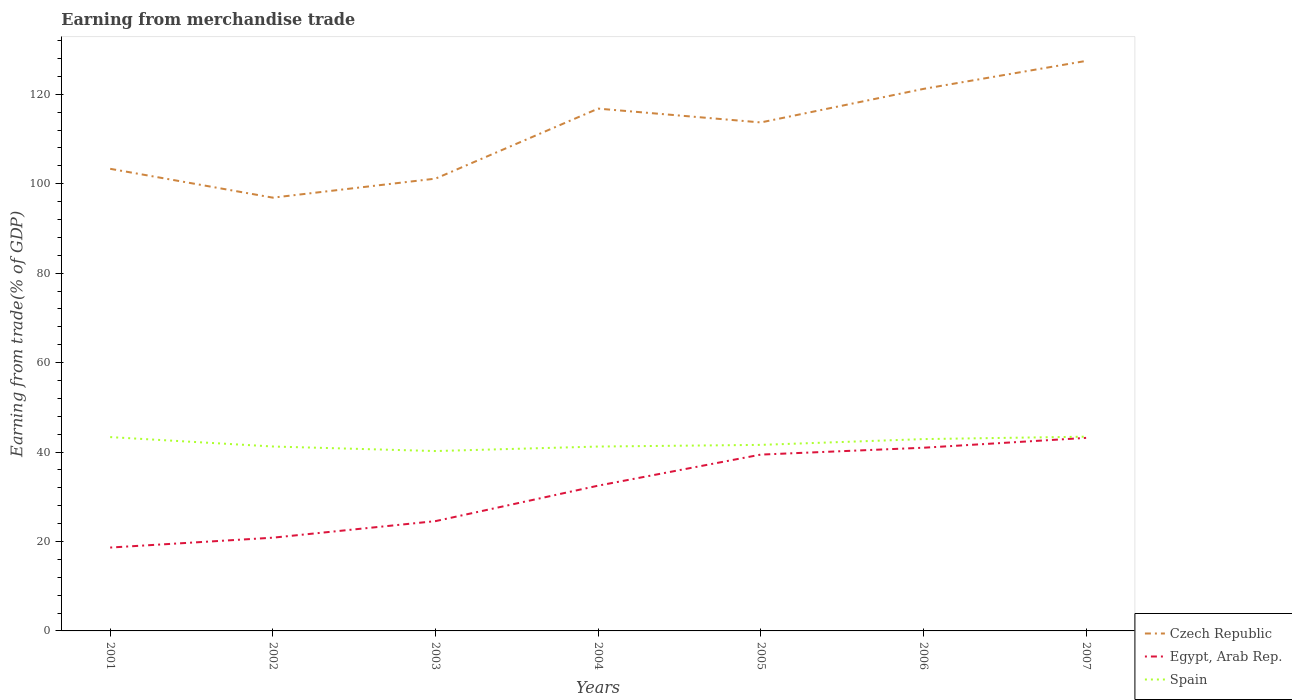Is the number of lines equal to the number of legend labels?
Provide a short and direct response. Yes. Across all years, what is the maximum earnings from trade in Egypt, Arab Rep.?
Provide a succinct answer. 18.64. In which year was the earnings from trade in Czech Republic maximum?
Your response must be concise. 2002. What is the total earnings from trade in Spain in the graph?
Your response must be concise. -0.36. What is the difference between the highest and the second highest earnings from trade in Czech Republic?
Provide a succinct answer. 30.58. Is the earnings from trade in Spain strictly greater than the earnings from trade in Czech Republic over the years?
Offer a terse response. Yes. How many lines are there?
Your answer should be compact. 3. How many years are there in the graph?
Ensure brevity in your answer.  7. Does the graph contain grids?
Offer a terse response. No. Where does the legend appear in the graph?
Provide a short and direct response. Bottom right. What is the title of the graph?
Your response must be concise. Earning from merchandise trade. What is the label or title of the Y-axis?
Give a very brief answer. Earning from trade(% of GDP). What is the Earning from trade(% of GDP) in Czech Republic in 2001?
Your answer should be compact. 103.33. What is the Earning from trade(% of GDP) of Egypt, Arab Rep. in 2001?
Your response must be concise. 18.64. What is the Earning from trade(% of GDP) in Spain in 2001?
Provide a short and direct response. 43.34. What is the Earning from trade(% of GDP) in Czech Republic in 2002?
Your answer should be very brief. 96.88. What is the Earning from trade(% of GDP) of Egypt, Arab Rep. in 2002?
Provide a short and direct response. 20.85. What is the Earning from trade(% of GDP) of Spain in 2002?
Your answer should be very brief. 41.24. What is the Earning from trade(% of GDP) in Czech Republic in 2003?
Make the answer very short. 101.14. What is the Earning from trade(% of GDP) in Egypt, Arab Rep. in 2003?
Ensure brevity in your answer.  24.55. What is the Earning from trade(% of GDP) in Spain in 2003?
Keep it short and to the point. 40.22. What is the Earning from trade(% of GDP) in Czech Republic in 2004?
Your answer should be compact. 116.79. What is the Earning from trade(% of GDP) in Egypt, Arab Rep. in 2004?
Your answer should be compact. 32.48. What is the Earning from trade(% of GDP) in Spain in 2004?
Provide a short and direct response. 41.23. What is the Earning from trade(% of GDP) of Czech Republic in 2005?
Ensure brevity in your answer.  113.7. What is the Earning from trade(% of GDP) of Egypt, Arab Rep. in 2005?
Your response must be concise. 39.43. What is the Earning from trade(% of GDP) of Spain in 2005?
Keep it short and to the point. 41.6. What is the Earning from trade(% of GDP) in Czech Republic in 2006?
Your answer should be very brief. 121.2. What is the Earning from trade(% of GDP) of Egypt, Arab Rep. in 2006?
Your response must be concise. 40.96. What is the Earning from trade(% of GDP) in Spain in 2006?
Ensure brevity in your answer.  42.89. What is the Earning from trade(% of GDP) in Czech Republic in 2007?
Offer a terse response. 127.46. What is the Earning from trade(% of GDP) in Egypt, Arab Rep. in 2007?
Your response must be concise. 43.17. What is the Earning from trade(% of GDP) of Spain in 2007?
Ensure brevity in your answer.  43.44. Across all years, what is the maximum Earning from trade(% of GDP) of Czech Republic?
Keep it short and to the point. 127.46. Across all years, what is the maximum Earning from trade(% of GDP) of Egypt, Arab Rep.?
Offer a very short reply. 43.17. Across all years, what is the maximum Earning from trade(% of GDP) of Spain?
Give a very brief answer. 43.44. Across all years, what is the minimum Earning from trade(% of GDP) in Czech Republic?
Keep it short and to the point. 96.88. Across all years, what is the minimum Earning from trade(% of GDP) in Egypt, Arab Rep.?
Keep it short and to the point. 18.64. Across all years, what is the minimum Earning from trade(% of GDP) in Spain?
Your answer should be compact. 40.22. What is the total Earning from trade(% of GDP) of Czech Republic in the graph?
Keep it short and to the point. 780.5. What is the total Earning from trade(% of GDP) of Egypt, Arab Rep. in the graph?
Your answer should be very brief. 220.08. What is the total Earning from trade(% of GDP) in Spain in the graph?
Keep it short and to the point. 293.96. What is the difference between the Earning from trade(% of GDP) of Czech Republic in 2001 and that in 2002?
Offer a terse response. 6.45. What is the difference between the Earning from trade(% of GDP) in Egypt, Arab Rep. in 2001 and that in 2002?
Offer a terse response. -2.21. What is the difference between the Earning from trade(% of GDP) in Spain in 2001 and that in 2002?
Ensure brevity in your answer.  2.1. What is the difference between the Earning from trade(% of GDP) in Czech Republic in 2001 and that in 2003?
Your response must be concise. 2.2. What is the difference between the Earning from trade(% of GDP) in Egypt, Arab Rep. in 2001 and that in 2003?
Provide a succinct answer. -5.91. What is the difference between the Earning from trade(% of GDP) in Spain in 2001 and that in 2003?
Keep it short and to the point. 3.12. What is the difference between the Earning from trade(% of GDP) in Czech Republic in 2001 and that in 2004?
Provide a succinct answer. -13.46. What is the difference between the Earning from trade(% of GDP) in Egypt, Arab Rep. in 2001 and that in 2004?
Make the answer very short. -13.84. What is the difference between the Earning from trade(% of GDP) of Spain in 2001 and that in 2004?
Ensure brevity in your answer.  2.11. What is the difference between the Earning from trade(% of GDP) in Czech Republic in 2001 and that in 2005?
Offer a very short reply. -10.37. What is the difference between the Earning from trade(% of GDP) in Egypt, Arab Rep. in 2001 and that in 2005?
Your answer should be very brief. -20.79. What is the difference between the Earning from trade(% of GDP) of Spain in 2001 and that in 2005?
Keep it short and to the point. 1.74. What is the difference between the Earning from trade(% of GDP) in Czech Republic in 2001 and that in 2006?
Ensure brevity in your answer.  -17.87. What is the difference between the Earning from trade(% of GDP) in Egypt, Arab Rep. in 2001 and that in 2006?
Ensure brevity in your answer.  -22.32. What is the difference between the Earning from trade(% of GDP) of Spain in 2001 and that in 2006?
Keep it short and to the point. 0.45. What is the difference between the Earning from trade(% of GDP) in Czech Republic in 2001 and that in 2007?
Provide a short and direct response. -24.13. What is the difference between the Earning from trade(% of GDP) in Egypt, Arab Rep. in 2001 and that in 2007?
Give a very brief answer. -24.53. What is the difference between the Earning from trade(% of GDP) in Spain in 2001 and that in 2007?
Make the answer very short. -0.1. What is the difference between the Earning from trade(% of GDP) of Czech Republic in 2002 and that in 2003?
Make the answer very short. -4.26. What is the difference between the Earning from trade(% of GDP) of Egypt, Arab Rep. in 2002 and that in 2003?
Give a very brief answer. -3.7. What is the difference between the Earning from trade(% of GDP) of Spain in 2002 and that in 2003?
Your answer should be very brief. 1.02. What is the difference between the Earning from trade(% of GDP) in Czech Republic in 2002 and that in 2004?
Your answer should be very brief. -19.91. What is the difference between the Earning from trade(% of GDP) of Egypt, Arab Rep. in 2002 and that in 2004?
Make the answer very short. -11.63. What is the difference between the Earning from trade(% of GDP) in Spain in 2002 and that in 2004?
Provide a succinct answer. 0.01. What is the difference between the Earning from trade(% of GDP) in Czech Republic in 2002 and that in 2005?
Keep it short and to the point. -16.82. What is the difference between the Earning from trade(% of GDP) in Egypt, Arab Rep. in 2002 and that in 2005?
Your answer should be compact. -18.58. What is the difference between the Earning from trade(% of GDP) in Spain in 2002 and that in 2005?
Your response must be concise. -0.36. What is the difference between the Earning from trade(% of GDP) in Czech Republic in 2002 and that in 2006?
Keep it short and to the point. -24.32. What is the difference between the Earning from trade(% of GDP) of Egypt, Arab Rep. in 2002 and that in 2006?
Give a very brief answer. -20.11. What is the difference between the Earning from trade(% of GDP) of Spain in 2002 and that in 2006?
Your response must be concise. -1.66. What is the difference between the Earning from trade(% of GDP) in Czech Republic in 2002 and that in 2007?
Offer a very short reply. -30.58. What is the difference between the Earning from trade(% of GDP) in Egypt, Arab Rep. in 2002 and that in 2007?
Your answer should be compact. -22.32. What is the difference between the Earning from trade(% of GDP) of Spain in 2002 and that in 2007?
Make the answer very short. -2.2. What is the difference between the Earning from trade(% of GDP) of Czech Republic in 2003 and that in 2004?
Keep it short and to the point. -15.65. What is the difference between the Earning from trade(% of GDP) in Egypt, Arab Rep. in 2003 and that in 2004?
Make the answer very short. -7.93. What is the difference between the Earning from trade(% of GDP) of Spain in 2003 and that in 2004?
Offer a terse response. -1.01. What is the difference between the Earning from trade(% of GDP) of Czech Republic in 2003 and that in 2005?
Keep it short and to the point. -12.56. What is the difference between the Earning from trade(% of GDP) of Egypt, Arab Rep. in 2003 and that in 2005?
Ensure brevity in your answer.  -14.88. What is the difference between the Earning from trade(% of GDP) in Spain in 2003 and that in 2005?
Provide a succinct answer. -1.38. What is the difference between the Earning from trade(% of GDP) in Czech Republic in 2003 and that in 2006?
Give a very brief answer. -20.06. What is the difference between the Earning from trade(% of GDP) in Egypt, Arab Rep. in 2003 and that in 2006?
Your answer should be compact. -16.41. What is the difference between the Earning from trade(% of GDP) of Spain in 2003 and that in 2006?
Keep it short and to the point. -2.67. What is the difference between the Earning from trade(% of GDP) of Czech Republic in 2003 and that in 2007?
Your response must be concise. -26.32. What is the difference between the Earning from trade(% of GDP) in Egypt, Arab Rep. in 2003 and that in 2007?
Your answer should be very brief. -18.62. What is the difference between the Earning from trade(% of GDP) of Spain in 2003 and that in 2007?
Offer a terse response. -3.22. What is the difference between the Earning from trade(% of GDP) in Czech Republic in 2004 and that in 2005?
Make the answer very short. 3.09. What is the difference between the Earning from trade(% of GDP) in Egypt, Arab Rep. in 2004 and that in 2005?
Make the answer very short. -6.94. What is the difference between the Earning from trade(% of GDP) in Spain in 2004 and that in 2005?
Provide a short and direct response. -0.37. What is the difference between the Earning from trade(% of GDP) in Czech Republic in 2004 and that in 2006?
Provide a succinct answer. -4.41. What is the difference between the Earning from trade(% of GDP) in Egypt, Arab Rep. in 2004 and that in 2006?
Give a very brief answer. -8.48. What is the difference between the Earning from trade(% of GDP) of Spain in 2004 and that in 2006?
Offer a very short reply. -1.67. What is the difference between the Earning from trade(% of GDP) in Czech Republic in 2004 and that in 2007?
Provide a succinct answer. -10.67. What is the difference between the Earning from trade(% of GDP) in Egypt, Arab Rep. in 2004 and that in 2007?
Your response must be concise. -10.68. What is the difference between the Earning from trade(% of GDP) of Spain in 2004 and that in 2007?
Provide a short and direct response. -2.21. What is the difference between the Earning from trade(% of GDP) in Czech Republic in 2005 and that in 2006?
Offer a very short reply. -7.5. What is the difference between the Earning from trade(% of GDP) in Egypt, Arab Rep. in 2005 and that in 2006?
Provide a succinct answer. -1.53. What is the difference between the Earning from trade(% of GDP) in Spain in 2005 and that in 2006?
Offer a terse response. -1.29. What is the difference between the Earning from trade(% of GDP) of Czech Republic in 2005 and that in 2007?
Provide a succinct answer. -13.76. What is the difference between the Earning from trade(% of GDP) of Egypt, Arab Rep. in 2005 and that in 2007?
Provide a short and direct response. -3.74. What is the difference between the Earning from trade(% of GDP) of Spain in 2005 and that in 2007?
Offer a terse response. -1.84. What is the difference between the Earning from trade(% of GDP) of Czech Republic in 2006 and that in 2007?
Keep it short and to the point. -6.26. What is the difference between the Earning from trade(% of GDP) of Egypt, Arab Rep. in 2006 and that in 2007?
Keep it short and to the point. -2.2. What is the difference between the Earning from trade(% of GDP) in Spain in 2006 and that in 2007?
Ensure brevity in your answer.  -0.54. What is the difference between the Earning from trade(% of GDP) of Czech Republic in 2001 and the Earning from trade(% of GDP) of Egypt, Arab Rep. in 2002?
Your response must be concise. 82.48. What is the difference between the Earning from trade(% of GDP) of Czech Republic in 2001 and the Earning from trade(% of GDP) of Spain in 2002?
Offer a terse response. 62.09. What is the difference between the Earning from trade(% of GDP) of Egypt, Arab Rep. in 2001 and the Earning from trade(% of GDP) of Spain in 2002?
Provide a short and direct response. -22.6. What is the difference between the Earning from trade(% of GDP) in Czech Republic in 2001 and the Earning from trade(% of GDP) in Egypt, Arab Rep. in 2003?
Make the answer very short. 78.78. What is the difference between the Earning from trade(% of GDP) of Czech Republic in 2001 and the Earning from trade(% of GDP) of Spain in 2003?
Ensure brevity in your answer.  63.11. What is the difference between the Earning from trade(% of GDP) of Egypt, Arab Rep. in 2001 and the Earning from trade(% of GDP) of Spain in 2003?
Your response must be concise. -21.58. What is the difference between the Earning from trade(% of GDP) of Czech Republic in 2001 and the Earning from trade(% of GDP) of Egypt, Arab Rep. in 2004?
Your response must be concise. 70.85. What is the difference between the Earning from trade(% of GDP) of Czech Republic in 2001 and the Earning from trade(% of GDP) of Spain in 2004?
Make the answer very short. 62.11. What is the difference between the Earning from trade(% of GDP) in Egypt, Arab Rep. in 2001 and the Earning from trade(% of GDP) in Spain in 2004?
Your answer should be compact. -22.59. What is the difference between the Earning from trade(% of GDP) of Czech Republic in 2001 and the Earning from trade(% of GDP) of Egypt, Arab Rep. in 2005?
Keep it short and to the point. 63.91. What is the difference between the Earning from trade(% of GDP) in Czech Republic in 2001 and the Earning from trade(% of GDP) in Spain in 2005?
Ensure brevity in your answer.  61.73. What is the difference between the Earning from trade(% of GDP) of Egypt, Arab Rep. in 2001 and the Earning from trade(% of GDP) of Spain in 2005?
Offer a terse response. -22.96. What is the difference between the Earning from trade(% of GDP) in Czech Republic in 2001 and the Earning from trade(% of GDP) in Egypt, Arab Rep. in 2006?
Keep it short and to the point. 62.37. What is the difference between the Earning from trade(% of GDP) of Czech Republic in 2001 and the Earning from trade(% of GDP) of Spain in 2006?
Make the answer very short. 60.44. What is the difference between the Earning from trade(% of GDP) in Egypt, Arab Rep. in 2001 and the Earning from trade(% of GDP) in Spain in 2006?
Give a very brief answer. -24.25. What is the difference between the Earning from trade(% of GDP) of Czech Republic in 2001 and the Earning from trade(% of GDP) of Egypt, Arab Rep. in 2007?
Your answer should be compact. 60.17. What is the difference between the Earning from trade(% of GDP) of Czech Republic in 2001 and the Earning from trade(% of GDP) of Spain in 2007?
Provide a succinct answer. 59.89. What is the difference between the Earning from trade(% of GDP) in Egypt, Arab Rep. in 2001 and the Earning from trade(% of GDP) in Spain in 2007?
Your answer should be very brief. -24.8. What is the difference between the Earning from trade(% of GDP) of Czech Republic in 2002 and the Earning from trade(% of GDP) of Egypt, Arab Rep. in 2003?
Offer a terse response. 72.33. What is the difference between the Earning from trade(% of GDP) of Czech Republic in 2002 and the Earning from trade(% of GDP) of Spain in 2003?
Make the answer very short. 56.66. What is the difference between the Earning from trade(% of GDP) in Egypt, Arab Rep. in 2002 and the Earning from trade(% of GDP) in Spain in 2003?
Make the answer very short. -19.37. What is the difference between the Earning from trade(% of GDP) of Czech Republic in 2002 and the Earning from trade(% of GDP) of Egypt, Arab Rep. in 2004?
Give a very brief answer. 64.4. What is the difference between the Earning from trade(% of GDP) in Czech Republic in 2002 and the Earning from trade(% of GDP) in Spain in 2004?
Provide a succinct answer. 55.65. What is the difference between the Earning from trade(% of GDP) in Egypt, Arab Rep. in 2002 and the Earning from trade(% of GDP) in Spain in 2004?
Offer a very short reply. -20.38. What is the difference between the Earning from trade(% of GDP) of Czech Republic in 2002 and the Earning from trade(% of GDP) of Egypt, Arab Rep. in 2005?
Give a very brief answer. 57.45. What is the difference between the Earning from trade(% of GDP) of Czech Republic in 2002 and the Earning from trade(% of GDP) of Spain in 2005?
Keep it short and to the point. 55.28. What is the difference between the Earning from trade(% of GDP) in Egypt, Arab Rep. in 2002 and the Earning from trade(% of GDP) in Spain in 2005?
Provide a succinct answer. -20.75. What is the difference between the Earning from trade(% of GDP) in Czech Republic in 2002 and the Earning from trade(% of GDP) in Egypt, Arab Rep. in 2006?
Make the answer very short. 55.92. What is the difference between the Earning from trade(% of GDP) in Czech Republic in 2002 and the Earning from trade(% of GDP) in Spain in 2006?
Your answer should be very brief. 53.99. What is the difference between the Earning from trade(% of GDP) in Egypt, Arab Rep. in 2002 and the Earning from trade(% of GDP) in Spain in 2006?
Make the answer very short. -22.05. What is the difference between the Earning from trade(% of GDP) in Czech Republic in 2002 and the Earning from trade(% of GDP) in Egypt, Arab Rep. in 2007?
Your answer should be compact. 53.71. What is the difference between the Earning from trade(% of GDP) in Czech Republic in 2002 and the Earning from trade(% of GDP) in Spain in 2007?
Your answer should be compact. 53.44. What is the difference between the Earning from trade(% of GDP) of Egypt, Arab Rep. in 2002 and the Earning from trade(% of GDP) of Spain in 2007?
Keep it short and to the point. -22.59. What is the difference between the Earning from trade(% of GDP) in Czech Republic in 2003 and the Earning from trade(% of GDP) in Egypt, Arab Rep. in 2004?
Offer a very short reply. 68.65. What is the difference between the Earning from trade(% of GDP) in Czech Republic in 2003 and the Earning from trade(% of GDP) in Spain in 2004?
Provide a short and direct response. 59.91. What is the difference between the Earning from trade(% of GDP) of Egypt, Arab Rep. in 2003 and the Earning from trade(% of GDP) of Spain in 2004?
Provide a succinct answer. -16.68. What is the difference between the Earning from trade(% of GDP) of Czech Republic in 2003 and the Earning from trade(% of GDP) of Egypt, Arab Rep. in 2005?
Make the answer very short. 61.71. What is the difference between the Earning from trade(% of GDP) in Czech Republic in 2003 and the Earning from trade(% of GDP) in Spain in 2005?
Ensure brevity in your answer.  59.54. What is the difference between the Earning from trade(% of GDP) in Egypt, Arab Rep. in 2003 and the Earning from trade(% of GDP) in Spain in 2005?
Offer a very short reply. -17.05. What is the difference between the Earning from trade(% of GDP) of Czech Republic in 2003 and the Earning from trade(% of GDP) of Egypt, Arab Rep. in 2006?
Keep it short and to the point. 60.17. What is the difference between the Earning from trade(% of GDP) of Czech Republic in 2003 and the Earning from trade(% of GDP) of Spain in 2006?
Make the answer very short. 58.24. What is the difference between the Earning from trade(% of GDP) in Egypt, Arab Rep. in 2003 and the Earning from trade(% of GDP) in Spain in 2006?
Give a very brief answer. -18.34. What is the difference between the Earning from trade(% of GDP) of Czech Republic in 2003 and the Earning from trade(% of GDP) of Egypt, Arab Rep. in 2007?
Your answer should be compact. 57.97. What is the difference between the Earning from trade(% of GDP) of Czech Republic in 2003 and the Earning from trade(% of GDP) of Spain in 2007?
Keep it short and to the point. 57.7. What is the difference between the Earning from trade(% of GDP) of Egypt, Arab Rep. in 2003 and the Earning from trade(% of GDP) of Spain in 2007?
Make the answer very short. -18.89. What is the difference between the Earning from trade(% of GDP) of Czech Republic in 2004 and the Earning from trade(% of GDP) of Egypt, Arab Rep. in 2005?
Provide a succinct answer. 77.36. What is the difference between the Earning from trade(% of GDP) in Czech Republic in 2004 and the Earning from trade(% of GDP) in Spain in 2005?
Provide a short and direct response. 75.19. What is the difference between the Earning from trade(% of GDP) in Egypt, Arab Rep. in 2004 and the Earning from trade(% of GDP) in Spain in 2005?
Your answer should be very brief. -9.12. What is the difference between the Earning from trade(% of GDP) of Czech Republic in 2004 and the Earning from trade(% of GDP) of Egypt, Arab Rep. in 2006?
Your answer should be compact. 75.83. What is the difference between the Earning from trade(% of GDP) of Czech Republic in 2004 and the Earning from trade(% of GDP) of Spain in 2006?
Provide a succinct answer. 73.9. What is the difference between the Earning from trade(% of GDP) of Egypt, Arab Rep. in 2004 and the Earning from trade(% of GDP) of Spain in 2006?
Your answer should be compact. -10.41. What is the difference between the Earning from trade(% of GDP) in Czech Republic in 2004 and the Earning from trade(% of GDP) in Egypt, Arab Rep. in 2007?
Your answer should be compact. 73.62. What is the difference between the Earning from trade(% of GDP) in Czech Republic in 2004 and the Earning from trade(% of GDP) in Spain in 2007?
Your response must be concise. 73.35. What is the difference between the Earning from trade(% of GDP) of Egypt, Arab Rep. in 2004 and the Earning from trade(% of GDP) of Spain in 2007?
Make the answer very short. -10.96. What is the difference between the Earning from trade(% of GDP) of Czech Republic in 2005 and the Earning from trade(% of GDP) of Egypt, Arab Rep. in 2006?
Your response must be concise. 72.74. What is the difference between the Earning from trade(% of GDP) in Czech Republic in 2005 and the Earning from trade(% of GDP) in Spain in 2006?
Make the answer very short. 70.81. What is the difference between the Earning from trade(% of GDP) of Egypt, Arab Rep. in 2005 and the Earning from trade(% of GDP) of Spain in 2006?
Provide a succinct answer. -3.47. What is the difference between the Earning from trade(% of GDP) in Czech Republic in 2005 and the Earning from trade(% of GDP) in Egypt, Arab Rep. in 2007?
Provide a succinct answer. 70.53. What is the difference between the Earning from trade(% of GDP) in Czech Republic in 2005 and the Earning from trade(% of GDP) in Spain in 2007?
Ensure brevity in your answer.  70.26. What is the difference between the Earning from trade(% of GDP) in Egypt, Arab Rep. in 2005 and the Earning from trade(% of GDP) in Spain in 2007?
Your answer should be compact. -4.01. What is the difference between the Earning from trade(% of GDP) in Czech Republic in 2006 and the Earning from trade(% of GDP) in Egypt, Arab Rep. in 2007?
Your response must be concise. 78.03. What is the difference between the Earning from trade(% of GDP) of Czech Republic in 2006 and the Earning from trade(% of GDP) of Spain in 2007?
Your response must be concise. 77.76. What is the difference between the Earning from trade(% of GDP) in Egypt, Arab Rep. in 2006 and the Earning from trade(% of GDP) in Spain in 2007?
Make the answer very short. -2.48. What is the average Earning from trade(% of GDP) of Czech Republic per year?
Make the answer very short. 111.5. What is the average Earning from trade(% of GDP) of Egypt, Arab Rep. per year?
Keep it short and to the point. 31.44. What is the average Earning from trade(% of GDP) of Spain per year?
Give a very brief answer. 41.99. In the year 2001, what is the difference between the Earning from trade(% of GDP) of Czech Republic and Earning from trade(% of GDP) of Egypt, Arab Rep.?
Keep it short and to the point. 84.69. In the year 2001, what is the difference between the Earning from trade(% of GDP) in Czech Republic and Earning from trade(% of GDP) in Spain?
Keep it short and to the point. 59.99. In the year 2001, what is the difference between the Earning from trade(% of GDP) of Egypt, Arab Rep. and Earning from trade(% of GDP) of Spain?
Offer a very short reply. -24.7. In the year 2002, what is the difference between the Earning from trade(% of GDP) in Czech Republic and Earning from trade(% of GDP) in Egypt, Arab Rep.?
Offer a very short reply. 76.03. In the year 2002, what is the difference between the Earning from trade(% of GDP) of Czech Republic and Earning from trade(% of GDP) of Spain?
Your answer should be very brief. 55.64. In the year 2002, what is the difference between the Earning from trade(% of GDP) in Egypt, Arab Rep. and Earning from trade(% of GDP) in Spain?
Offer a terse response. -20.39. In the year 2003, what is the difference between the Earning from trade(% of GDP) in Czech Republic and Earning from trade(% of GDP) in Egypt, Arab Rep.?
Keep it short and to the point. 76.59. In the year 2003, what is the difference between the Earning from trade(% of GDP) in Czech Republic and Earning from trade(% of GDP) in Spain?
Make the answer very short. 60.92. In the year 2003, what is the difference between the Earning from trade(% of GDP) of Egypt, Arab Rep. and Earning from trade(% of GDP) of Spain?
Offer a very short reply. -15.67. In the year 2004, what is the difference between the Earning from trade(% of GDP) of Czech Republic and Earning from trade(% of GDP) of Egypt, Arab Rep.?
Provide a succinct answer. 84.31. In the year 2004, what is the difference between the Earning from trade(% of GDP) of Czech Republic and Earning from trade(% of GDP) of Spain?
Provide a succinct answer. 75.56. In the year 2004, what is the difference between the Earning from trade(% of GDP) of Egypt, Arab Rep. and Earning from trade(% of GDP) of Spain?
Your response must be concise. -8.74. In the year 2005, what is the difference between the Earning from trade(% of GDP) of Czech Republic and Earning from trade(% of GDP) of Egypt, Arab Rep.?
Offer a terse response. 74.27. In the year 2005, what is the difference between the Earning from trade(% of GDP) in Czech Republic and Earning from trade(% of GDP) in Spain?
Provide a succinct answer. 72.1. In the year 2005, what is the difference between the Earning from trade(% of GDP) of Egypt, Arab Rep. and Earning from trade(% of GDP) of Spain?
Make the answer very short. -2.17. In the year 2006, what is the difference between the Earning from trade(% of GDP) of Czech Republic and Earning from trade(% of GDP) of Egypt, Arab Rep.?
Make the answer very short. 80.24. In the year 2006, what is the difference between the Earning from trade(% of GDP) of Czech Republic and Earning from trade(% of GDP) of Spain?
Provide a short and direct response. 78.31. In the year 2006, what is the difference between the Earning from trade(% of GDP) of Egypt, Arab Rep. and Earning from trade(% of GDP) of Spain?
Make the answer very short. -1.93. In the year 2007, what is the difference between the Earning from trade(% of GDP) in Czech Republic and Earning from trade(% of GDP) in Egypt, Arab Rep.?
Your answer should be very brief. 84.29. In the year 2007, what is the difference between the Earning from trade(% of GDP) of Czech Republic and Earning from trade(% of GDP) of Spain?
Your answer should be very brief. 84.02. In the year 2007, what is the difference between the Earning from trade(% of GDP) of Egypt, Arab Rep. and Earning from trade(% of GDP) of Spain?
Provide a short and direct response. -0.27. What is the ratio of the Earning from trade(% of GDP) of Czech Republic in 2001 to that in 2002?
Your response must be concise. 1.07. What is the ratio of the Earning from trade(% of GDP) in Egypt, Arab Rep. in 2001 to that in 2002?
Provide a short and direct response. 0.89. What is the ratio of the Earning from trade(% of GDP) in Spain in 2001 to that in 2002?
Offer a terse response. 1.05. What is the ratio of the Earning from trade(% of GDP) of Czech Republic in 2001 to that in 2003?
Make the answer very short. 1.02. What is the ratio of the Earning from trade(% of GDP) in Egypt, Arab Rep. in 2001 to that in 2003?
Provide a succinct answer. 0.76. What is the ratio of the Earning from trade(% of GDP) of Spain in 2001 to that in 2003?
Give a very brief answer. 1.08. What is the ratio of the Earning from trade(% of GDP) in Czech Republic in 2001 to that in 2004?
Ensure brevity in your answer.  0.88. What is the ratio of the Earning from trade(% of GDP) in Egypt, Arab Rep. in 2001 to that in 2004?
Your answer should be compact. 0.57. What is the ratio of the Earning from trade(% of GDP) in Spain in 2001 to that in 2004?
Offer a very short reply. 1.05. What is the ratio of the Earning from trade(% of GDP) in Czech Republic in 2001 to that in 2005?
Make the answer very short. 0.91. What is the ratio of the Earning from trade(% of GDP) in Egypt, Arab Rep. in 2001 to that in 2005?
Your answer should be compact. 0.47. What is the ratio of the Earning from trade(% of GDP) in Spain in 2001 to that in 2005?
Provide a short and direct response. 1.04. What is the ratio of the Earning from trade(% of GDP) of Czech Republic in 2001 to that in 2006?
Keep it short and to the point. 0.85. What is the ratio of the Earning from trade(% of GDP) in Egypt, Arab Rep. in 2001 to that in 2006?
Your answer should be compact. 0.46. What is the ratio of the Earning from trade(% of GDP) in Spain in 2001 to that in 2006?
Provide a short and direct response. 1.01. What is the ratio of the Earning from trade(% of GDP) of Czech Republic in 2001 to that in 2007?
Make the answer very short. 0.81. What is the ratio of the Earning from trade(% of GDP) in Egypt, Arab Rep. in 2001 to that in 2007?
Make the answer very short. 0.43. What is the ratio of the Earning from trade(% of GDP) in Czech Republic in 2002 to that in 2003?
Offer a very short reply. 0.96. What is the ratio of the Earning from trade(% of GDP) in Egypt, Arab Rep. in 2002 to that in 2003?
Offer a terse response. 0.85. What is the ratio of the Earning from trade(% of GDP) of Spain in 2002 to that in 2003?
Provide a succinct answer. 1.03. What is the ratio of the Earning from trade(% of GDP) in Czech Republic in 2002 to that in 2004?
Offer a terse response. 0.83. What is the ratio of the Earning from trade(% of GDP) of Egypt, Arab Rep. in 2002 to that in 2004?
Keep it short and to the point. 0.64. What is the ratio of the Earning from trade(% of GDP) in Czech Republic in 2002 to that in 2005?
Provide a succinct answer. 0.85. What is the ratio of the Earning from trade(% of GDP) of Egypt, Arab Rep. in 2002 to that in 2005?
Provide a succinct answer. 0.53. What is the ratio of the Earning from trade(% of GDP) of Czech Republic in 2002 to that in 2006?
Your answer should be compact. 0.8. What is the ratio of the Earning from trade(% of GDP) in Egypt, Arab Rep. in 2002 to that in 2006?
Your response must be concise. 0.51. What is the ratio of the Earning from trade(% of GDP) of Spain in 2002 to that in 2006?
Provide a succinct answer. 0.96. What is the ratio of the Earning from trade(% of GDP) of Czech Republic in 2002 to that in 2007?
Keep it short and to the point. 0.76. What is the ratio of the Earning from trade(% of GDP) of Egypt, Arab Rep. in 2002 to that in 2007?
Provide a short and direct response. 0.48. What is the ratio of the Earning from trade(% of GDP) in Spain in 2002 to that in 2007?
Provide a short and direct response. 0.95. What is the ratio of the Earning from trade(% of GDP) of Czech Republic in 2003 to that in 2004?
Your response must be concise. 0.87. What is the ratio of the Earning from trade(% of GDP) of Egypt, Arab Rep. in 2003 to that in 2004?
Offer a terse response. 0.76. What is the ratio of the Earning from trade(% of GDP) in Spain in 2003 to that in 2004?
Ensure brevity in your answer.  0.98. What is the ratio of the Earning from trade(% of GDP) of Czech Republic in 2003 to that in 2005?
Make the answer very short. 0.89. What is the ratio of the Earning from trade(% of GDP) of Egypt, Arab Rep. in 2003 to that in 2005?
Give a very brief answer. 0.62. What is the ratio of the Earning from trade(% of GDP) of Spain in 2003 to that in 2005?
Your response must be concise. 0.97. What is the ratio of the Earning from trade(% of GDP) in Czech Republic in 2003 to that in 2006?
Keep it short and to the point. 0.83. What is the ratio of the Earning from trade(% of GDP) in Egypt, Arab Rep. in 2003 to that in 2006?
Offer a terse response. 0.6. What is the ratio of the Earning from trade(% of GDP) in Spain in 2003 to that in 2006?
Ensure brevity in your answer.  0.94. What is the ratio of the Earning from trade(% of GDP) in Czech Republic in 2003 to that in 2007?
Provide a succinct answer. 0.79. What is the ratio of the Earning from trade(% of GDP) in Egypt, Arab Rep. in 2003 to that in 2007?
Ensure brevity in your answer.  0.57. What is the ratio of the Earning from trade(% of GDP) of Spain in 2003 to that in 2007?
Ensure brevity in your answer.  0.93. What is the ratio of the Earning from trade(% of GDP) of Czech Republic in 2004 to that in 2005?
Make the answer very short. 1.03. What is the ratio of the Earning from trade(% of GDP) of Egypt, Arab Rep. in 2004 to that in 2005?
Your answer should be very brief. 0.82. What is the ratio of the Earning from trade(% of GDP) in Spain in 2004 to that in 2005?
Provide a short and direct response. 0.99. What is the ratio of the Earning from trade(% of GDP) in Czech Republic in 2004 to that in 2006?
Give a very brief answer. 0.96. What is the ratio of the Earning from trade(% of GDP) of Egypt, Arab Rep. in 2004 to that in 2006?
Your answer should be very brief. 0.79. What is the ratio of the Earning from trade(% of GDP) in Spain in 2004 to that in 2006?
Your answer should be compact. 0.96. What is the ratio of the Earning from trade(% of GDP) of Czech Republic in 2004 to that in 2007?
Keep it short and to the point. 0.92. What is the ratio of the Earning from trade(% of GDP) of Egypt, Arab Rep. in 2004 to that in 2007?
Offer a very short reply. 0.75. What is the ratio of the Earning from trade(% of GDP) in Spain in 2004 to that in 2007?
Your response must be concise. 0.95. What is the ratio of the Earning from trade(% of GDP) in Czech Republic in 2005 to that in 2006?
Make the answer very short. 0.94. What is the ratio of the Earning from trade(% of GDP) in Egypt, Arab Rep. in 2005 to that in 2006?
Make the answer very short. 0.96. What is the ratio of the Earning from trade(% of GDP) of Spain in 2005 to that in 2006?
Make the answer very short. 0.97. What is the ratio of the Earning from trade(% of GDP) in Czech Republic in 2005 to that in 2007?
Offer a very short reply. 0.89. What is the ratio of the Earning from trade(% of GDP) in Egypt, Arab Rep. in 2005 to that in 2007?
Keep it short and to the point. 0.91. What is the ratio of the Earning from trade(% of GDP) of Spain in 2005 to that in 2007?
Your answer should be compact. 0.96. What is the ratio of the Earning from trade(% of GDP) in Czech Republic in 2006 to that in 2007?
Your answer should be compact. 0.95. What is the ratio of the Earning from trade(% of GDP) in Egypt, Arab Rep. in 2006 to that in 2007?
Keep it short and to the point. 0.95. What is the ratio of the Earning from trade(% of GDP) in Spain in 2006 to that in 2007?
Offer a terse response. 0.99. What is the difference between the highest and the second highest Earning from trade(% of GDP) in Czech Republic?
Your response must be concise. 6.26. What is the difference between the highest and the second highest Earning from trade(% of GDP) of Egypt, Arab Rep.?
Ensure brevity in your answer.  2.2. What is the difference between the highest and the second highest Earning from trade(% of GDP) in Spain?
Your answer should be very brief. 0.1. What is the difference between the highest and the lowest Earning from trade(% of GDP) of Czech Republic?
Keep it short and to the point. 30.58. What is the difference between the highest and the lowest Earning from trade(% of GDP) of Egypt, Arab Rep.?
Offer a very short reply. 24.53. What is the difference between the highest and the lowest Earning from trade(% of GDP) of Spain?
Provide a short and direct response. 3.22. 